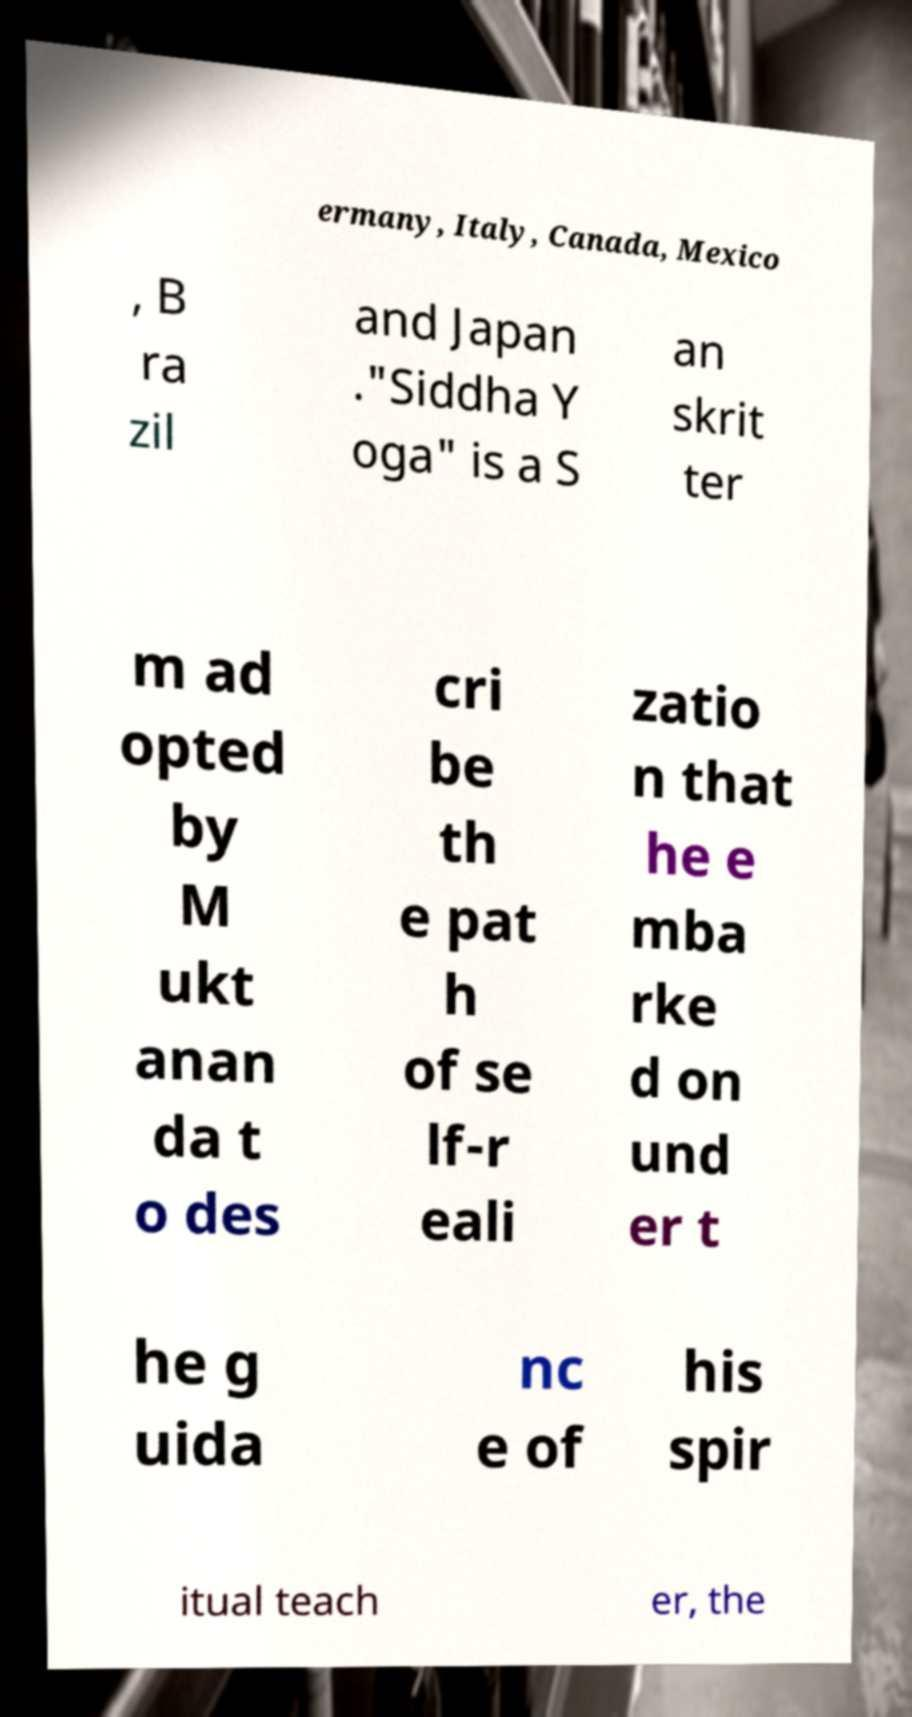Could you assist in decoding the text presented in this image and type it out clearly? ermany, Italy, Canada, Mexico , B ra zil and Japan ."Siddha Y oga" is a S an skrit ter m ad opted by M ukt anan da t o des cri be th e pat h of se lf-r eali zatio n that he e mba rke d on und er t he g uida nc e of his spir itual teach er, the 